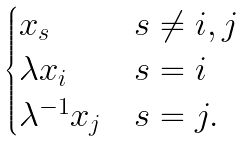Convert formula to latex. <formula><loc_0><loc_0><loc_500><loc_500>\begin{cases} x _ { s } & s \neq i , j \\ \lambda x _ { i } & s = i \\ \lambda ^ { - 1 } x _ { j } & s = j . \end{cases}</formula> 